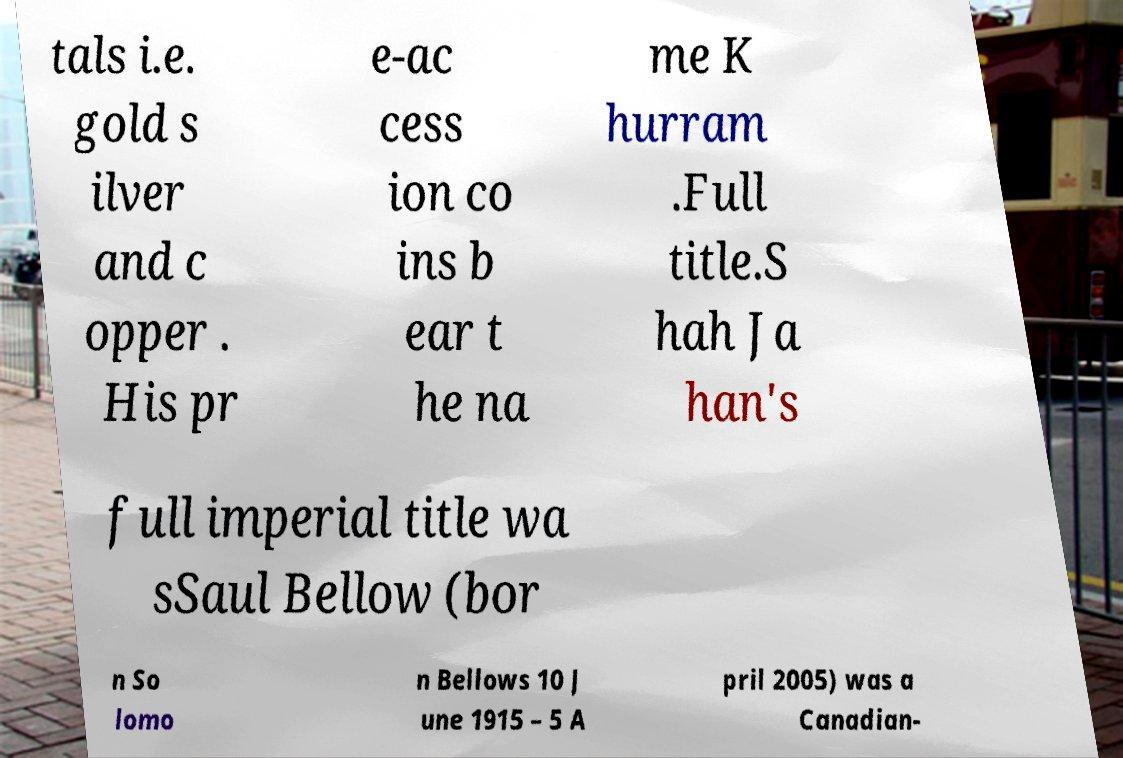What messages or text are displayed in this image? I need them in a readable, typed format. tals i.e. gold s ilver and c opper . His pr e-ac cess ion co ins b ear t he na me K hurram .Full title.S hah Ja han's full imperial title wa sSaul Bellow (bor n So lomo n Bellows 10 J une 1915 – 5 A pril 2005) was a Canadian- 